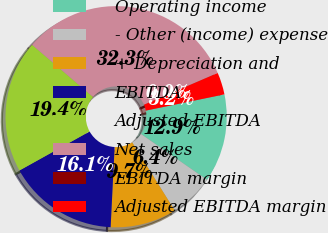Convert chart to OTSL. <chart><loc_0><loc_0><loc_500><loc_500><pie_chart><fcel>Operating income<fcel>- Other (income) expense<fcel>+ Depreciation and<fcel>EBITDA<fcel>Adjusted EBITDA<fcel>Net sales<fcel>EBITDA margin<fcel>Adjusted EBITDA margin<nl><fcel>12.9%<fcel>6.45%<fcel>9.68%<fcel>16.13%<fcel>19.35%<fcel>32.26%<fcel>0.0%<fcel>3.23%<nl></chart> 